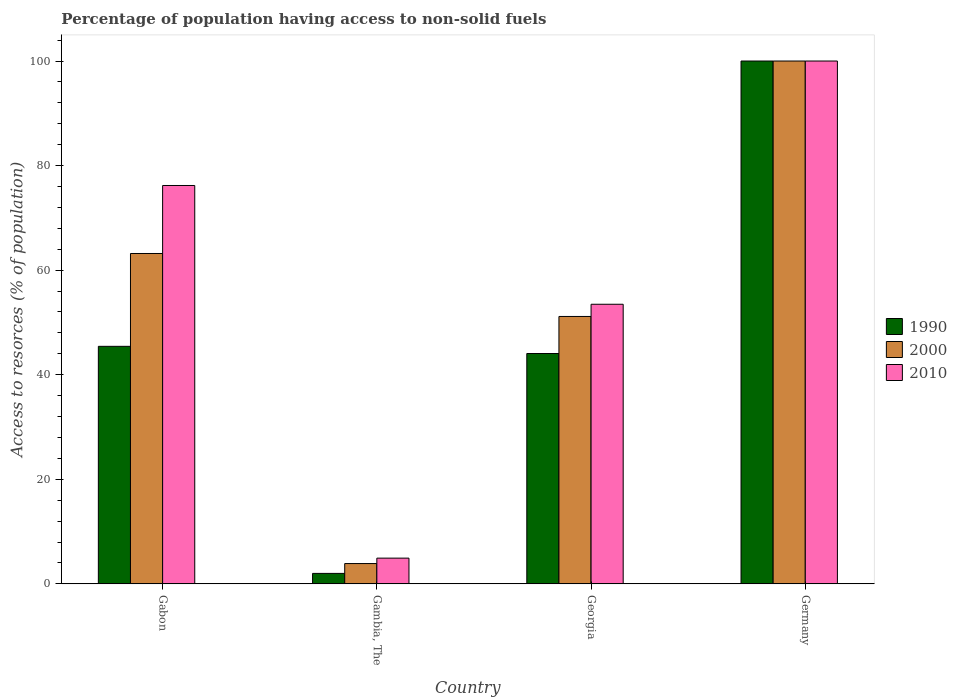How many different coloured bars are there?
Offer a terse response. 3. How many groups of bars are there?
Your answer should be compact. 4. Are the number of bars per tick equal to the number of legend labels?
Offer a terse response. Yes. Are the number of bars on each tick of the X-axis equal?
Provide a short and direct response. Yes. What is the label of the 4th group of bars from the left?
Ensure brevity in your answer.  Germany. In how many cases, is the number of bars for a given country not equal to the number of legend labels?
Provide a short and direct response. 0. What is the percentage of population having access to non-solid fuels in 2000 in Germany?
Your answer should be very brief. 100. Across all countries, what is the minimum percentage of population having access to non-solid fuels in 1990?
Provide a short and direct response. 2. In which country was the percentage of population having access to non-solid fuels in 2010 maximum?
Ensure brevity in your answer.  Germany. In which country was the percentage of population having access to non-solid fuels in 2010 minimum?
Ensure brevity in your answer.  Gambia, The. What is the total percentage of population having access to non-solid fuels in 1990 in the graph?
Give a very brief answer. 191.49. What is the difference between the percentage of population having access to non-solid fuels in 1990 in Gabon and that in Georgia?
Make the answer very short. 1.37. What is the difference between the percentage of population having access to non-solid fuels in 2000 in Germany and the percentage of population having access to non-solid fuels in 1990 in Gambia, The?
Ensure brevity in your answer.  98. What is the average percentage of population having access to non-solid fuels in 1990 per country?
Your answer should be compact. 47.87. In how many countries, is the percentage of population having access to non-solid fuels in 1990 greater than 72 %?
Give a very brief answer. 1. What is the ratio of the percentage of population having access to non-solid fuels in 1990 in Gambia, The to that in Germany?
Provide a succinct answer. 0.02. Is the percentage of population having access to non-solid fuels in 2000 in Gabon less than that in Gambia, The?
Keep it short and to the point. No. What is the difference between the highest and the second highest percentage of population having access to non-solid fuels in 2000?
Give a very brief answer. -48.86. What is the difference between the highest and the lowest percentage of population having access to non-solid fuels in 2010?
Your answer should be compact. 95.08. What does the 3rd bar from the left in Georgia represents?
Make the answer very short. 2010. What does the 3rd bar from the right in Gabon represents?
Keep it short and to the point. 1990. Are all the bars in the graph horizontal?
Offer a terse response. No. How many countries are there in the graph?
Offer a very short reply. 4. What is the difference between two consecutive major ticks on the Y-axis?
Keep it short and to the point. 20. Are the values on the major ticks of Y-axis written in scientific E-notation?
Ensure brevity in your answer.  No. Where does the legend appear in the graph?
Provide a succinct answer. Center right. What is the title of the graph?
Offer a terse response. Percentage of population having access to non-solid fuels. What is the label or title of the Y-axis?
Make the answer very short. Access to resorces (% of population). What is the Access to resorces (% of population) of 1990 in Gabon?
Make the answer very short. 45.43. What is the Access to resorces (% of population) of 2000 in Gabon?
Your response must be concise. 63.19. What is the Access to resorces (% of population) in 2010 in Gabon?
Offer a terse response. 76.19. What is the Access to resorces (% of population) of 1990 in Gambia, The?
Give a very brief answer. 2. What is the Access to resorces (% of population) of 2000 in Gambia, The?
Ensure brevity in your answer.  3.88. What is the Access to resorces (% of population) in 2010 in Gambia, The?
Ensure brevity in your answer.  4.92. What is the Access to resorces (% of population) of 1990 in Georgia?
Your answer should be compact. 44.06. What is the Access to resorces (% of population) of 2000 in Georgia?
Offer a terse response. 51.14. What is the Access to resorces (% of population) in 2010 in Georgia?
Ensure brevity in your answer.  53.48. Across all countries, what is the maximum Access to resorces (% of population) of 2000?
Provide a succinct answer. 100. Across all countries, what is the maximum Access to resorces (% of population) in 2010?
Your answer should be compact. 100. Across all countries, what is the minimum Access to resorces (% of population) of 1990?
Your answer should be very brief. 2. Across all countries, what is the minimum Access to resorces (% of population) of 2000?
Offer a terse response. 3.88. Across all countries, what is the minimum Access to resorces (% of population) of 2010?
Offer a very short reply. 4.92. What is the total Access to resorces (% of population) in 1990 in the graph?
Make the answer very short. 191.49. What is the total Access to resorces (% of population) of 2000 in the graph?
Ensure brevity in your answer.  218.21. What is the total Access to resorces (% of population) in 2010 in the graph?
Provide a succinct answer. 234.59. What is the difference between the Access to resorces (% of population) in 1990 in Gabon and that in Gambia, The?
Provide a short and direct response. 43.43. What is the difference between the Access to resorces (% of population) of 2000 in Gabon and that in Gambia, The?
Keep it short and to the point. 59.3. What is the difference between the Access to resorces (% of population) in 2010 in Gabon and that in Gambia, The?
Make the answer very short. 71.27. What is the difference between the Access to resorces (% of population) in 1990 in Gabon and that in Georgia?
Provide a succinct answer. 1.37. What is the difference between the Access to resorces (% of population) in 2000 in Gabon and that in Georgia?
Your answer should be compact. 12.04. What is the difference between the Access to resorces (% of population) in 2010 in Gabon and that in Georgia?
Offer a very short reply. 22.72. What is the difference between the Access to resorces (% of population) in 1990 in Gabon and that in Germany?
Offer a very short reply. -54.57. What is the difference between the Access to resorces (% of population) in 2000 in Gabon and that in Germany?
Ensure brevity in your answer.  -36.81. What is the difference between the Access to resorces (% of population) in 2010 in Gabon and that in Germany?
Offer a terse response. -23.81. What is the difference between the Access to resorces (% of population) of 1990 in Gambia, The and that in Georgia?
Your answer should be very brief. -42.06. What is the difference between the Access to resorces (% of population) of 2000 in Gambia, The and that in Georgia?
Offer a very short reply. -47.26. What is the difference between the Access to resorces (% of population) of 2010 in Gambia, The and that in Georgia?
Make the answer very short. -48.56. What is the difference between the Access to resorces (% of population) in 1990 in Gambia, The and that in Germany?
Provide a short and direct response. -98. What is the difference between the Access to resorces (% of population) in 2000 in Gambia, The and that in Germany?
Offer a terse response. -96.12. What is the difference between the Access to resorces (% of population) in 2010 in Gambia, The and that in Germany?
Your answer should be very brief. -95.08. What is the difference between the Access to resorces (% of population) in 1990 in Georgia and that in Germany?
Provide a short and direct response. -55.94. What is the difference between the Access to resorces (% of population) of 2000 in Georgia and that in Germany?
Your response must be concise. -48.86. What is the difference between the Access to resorces (% of population) in 2010 in Georgia and that in Germany?
Offer a very short reply. -46.52. What is the difference between the Access to resorces (% of population) in 1990 in Gabon and the Access to resorces (% of population) in 2000 in Gambia, The?
Make the answer very short. 41.55. What is the difference between the Access to resorces (% of population) of 1990 in Gabon and the Access to resorces (% of population) of 2010 in Gambia, The?
Ensure brevity in your answer.  40.51. What is the difference between the Access to resorces (% of population) in 2000 in Gabon and the Access to resorces (% of population) in 2010 in Gambia, The?
Give a very brief answer. 58.26. What is the difference between the Access to resorces (% of population) of 1990 in Gabon and the Access to resorces (% of population) of 2000 in Georgia?
Your answer should be compact. -5.71. What is the difference between the Access to resorces (% of population) in 1990 in Gabon and the Access to resorces (% of population) in 2010 in Georgia?
Offer a very short reply. -8.05. What is the difference between the Access to resorces (% of population) in 2000 in Gabon and the Access to resorces (% of population) in 2010 in Georgia?
Your answer should be very brief. 9.71. What is the difference between the Access to resorces (% of population) in 1990 in Gabon and the Access to resorces (% of population) in 2000 in Germany?
Keep it short and to the point. -54.57. What is the difference between the Access to resorces (% of population) in 1990 in Gabon and the Access to resorces (% of population) in 2010 in Germany?
Give a very brief answer. -54.57. What is the difference between the Access to resorces (% of population) in 2000 in Gabon and the Access to resorces (% of population) in 2010 in Germany?
Your answer should be compact. -36.81. What is the difference between the Access to resorces (% of population) in 1990 in Gambia, The and the Access to resorces (% of population) in 2000 in Georgia?
Your answer should be compact. -49.14. What is the difference between the Access to resorces (% of population) in 1990 in Gambia, The and the Access to resorces (% of population) in 2010 in Georgia?
Provide a short and direct response. -51.48. What is the difference between the Access to resorces (% of population) of 2000 in Gambia, The and the Access to resorces (% of population) of 2010 in Georgia?
Your answer should be compact. -49.59. What is the difference between the Access to resorces (% of population) of 1990 in Gambia, The and the Access to resorces (% of population) of 2000 in Germany?
Provide a short and direct response. -98. What is the difference between the Access to resorces (% of population) of 1990 in Gambia, The and the Access to resorces (% of population) of 2010 in Germany?
Provide a short and direct response. -98. What is the difference between the Access to resorces (% of population) in 2000 in Gambia, The and the Access to resorces (% of population) in 2010 in Germany?
Your answer should be compact. -96.12. What is the difference between the Access to resorces (% of population) of 1990 in Georgia and the Access to resorces (% of population) of 2000 in Germany?
Offer a very short reply. -55.94. What is the difference between the Access to resorces (% of population) of 1990 in Georgia and the Access to resorces (% of population) of 2010 in Germany?
Offer a very short reply. -55.94. What is the difference between the Access to resorces (% of population) of 2000 in Georgia and the Access to resorces (% of population) of 2010 in Germany?
Provide a short and direct response. -48.86. What is the average Access to resorces (% of population) in 1990 per country?
Provide a succinct answer. 47.87. What is the average Access to resorces (% of population) of 2000 per country?
Your response must be concise. 54.55. What is the average Access to resorces (% of population) in 2010 per country?
Your answer should be very brief. 58.65. What is the difference between the Access to resorces (% of population) in 1990 and Access to resorces (% of population) in 2000 in Gabon?
Keep it short and to the point. -17.76. What is the difference between the Access to resorces (% of population) in 1990 and Access to resorces (% of population) in 2010 in Gabon?
Offer a very short reply. -30.76. What is the difference between the Access to resorces (% of population) in 2000 and Access to resorces (% of population) in 2010 in Gabon?
Give a very brief answer. -13.01. What is the difference between the Access to resorces (% of population) in 1990 and Access to resorces (% of population) in 2000 in Gambia, The?
Provide a short and direct response. -1.88. What is the difference between the Access to resorces (% of population) in 1990 and Access to resorces (% of population) in 2010 in Gambia, The?
Make the answer very short. -2.92. What is the difference between the Access to resorces (% of population) of 2000 and Access to resorces (% of population) of 2010 in Gambia, The?
Make the answer very short. -1.04. What is the difference between the Access to resorces (% of population) in 1990 and Access to resorces (% of population) in 2000 in Georgia?
Make the answer very short. -7.08. What is the difference between the Access to resorces (% of population) of 1990 and Access to resorces (% of population) of 2010 in Georgia?
Keep it short and to the point. -9.42. What is the difference between the Access to resorces (% of population) of 2000 and Access to resorces (% of population) of 2010 in Georgia?
Offer a very short reply. -2.33. What is the difference between the Access to resorces (% of population) in 1990 and Access to resorces (% of population) in 2010 in Germany?
Ensure brevity in your answer.  0. What is the ratio of the Access to resorces (% of population) of 1990 in Gabon to that in Gambia, The?
Give a very brief answer. 22.71. What is the ratio of the Access to resorces (% of population) of 2000 in Gabon to that in Gambia, The?
Your answer should be very brief. 16.27. What is the ratio of the Access to resorces (% of population) in 2010 in Gabon to that in Gambia, The?
Provide a succinct answer. 15.48. What is the ratio of the Access to resorces (% of population) in 1990 in Gabon to that in Georgia?
Your response must be concise. 1.03. What is the ratio of the Access to resorces (% of population) of 2000 in Gabon to that in Georgia?
Keep it short and to the point. 1.24. What is the ratio of the Access to resorces (% of population) of 2010 in Gabon to that in Georgia?
Provide a succinct answer. 1.42. What is the ratio of the Access to resorces (% of population) in 1990 in Gabon to that in Germany?
Offer a terse response. 0.45. What is the ratio of the Access to resorces (% of population) in 2000 in Gabon to that in Germany?
Your answer should be compact. 0.63. What is the ratio of the Access to resorces (% of population) of 2010 in Gabon to that in Germany?
Give a very brief answer. 0.76. What is the ratio of the Access to resorces (% of population) in 1990 in Gambia, The to that in Georgia?
Offer a very short reply. 0.05. What is the ratio of the Access to resorces (% of population) of 2000 in Gambia, The to that in Georgia?
Your answer should be compact. 0.08. What is the ratio of the Access to resorces (% of population) in 2010 in Gambia, The to that in Georgia?
Your response must be concise. 0.09. What is the ratio of the Access to resorces (% of population) in 1990 in Gambia, The to that in Germany?
Give a very brief answer. 0.02. What is the ratio of the Access to resorces (% of population) in 2000 in Gambia, The to that in Germany?
Give a very brief answer. 0.04. What is the ratio of the Access to resorces (% of population) in 2010 in Gambia, The to that in Germany?
Your response must be concise. 0.05. What is the ratio of the Access to resorces (% of population) in 1990 in Georgia to that in Germany?
Ensure brevity in your answer.  0.44. What is the ratio of the Access to resorces (% of population) of 2000 in Georgia to that in Germany?
Your answer should be compact. 0.51. What is the ratio of the Access to resorces (% of population) in 2010 in Georgia to that in Germany?
Offer a very short reply. 0.53. What is the difference between the highest and the second highest Access to resorces (% of population) in 1990?
Offer a very short reply. 54.57. What is the difference between the highest and the second highest Access to resorces (% of population) in 2000?
Your answer should be compact. 36.81. What is the difference between the highest and the second highest Access to resorces (% of population) of 2010?
Provide a succinct answer. 23.81. What is the difference between the highest and the lowest Access to resorces (% of population) in 2000?
Your answer should be compact. 96.12. What is the difference between the highest and the lowest Access to resorces (% of population) in 2010?
Make the answer very short. 95.08. 